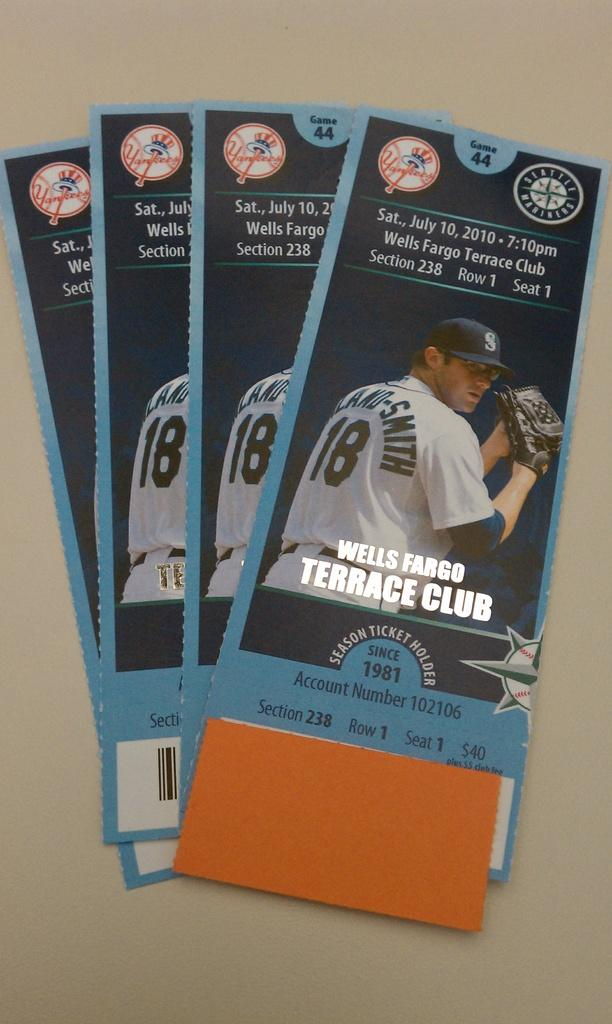<image>
Relay a brief, clear account of the picture shown. the word terrace that is on a ticket 